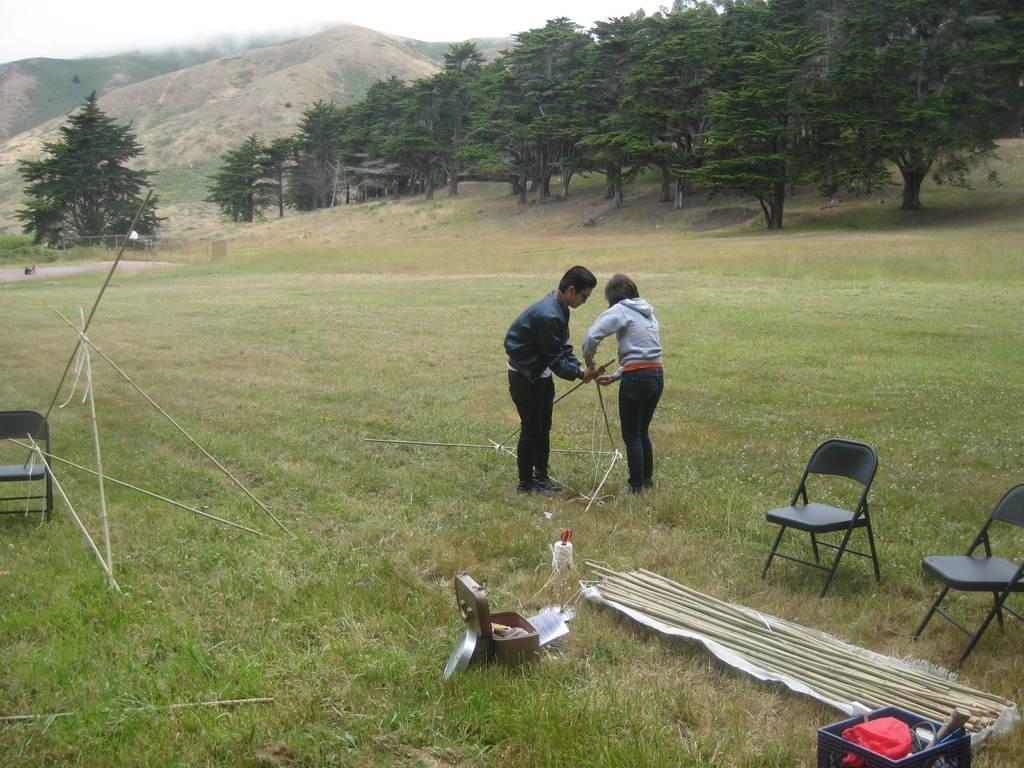How would you summarize this image in a sentence or two? In this picture we can see 2 people holding wooden poles and standing on the grass field surrounded by trees and mountains. 